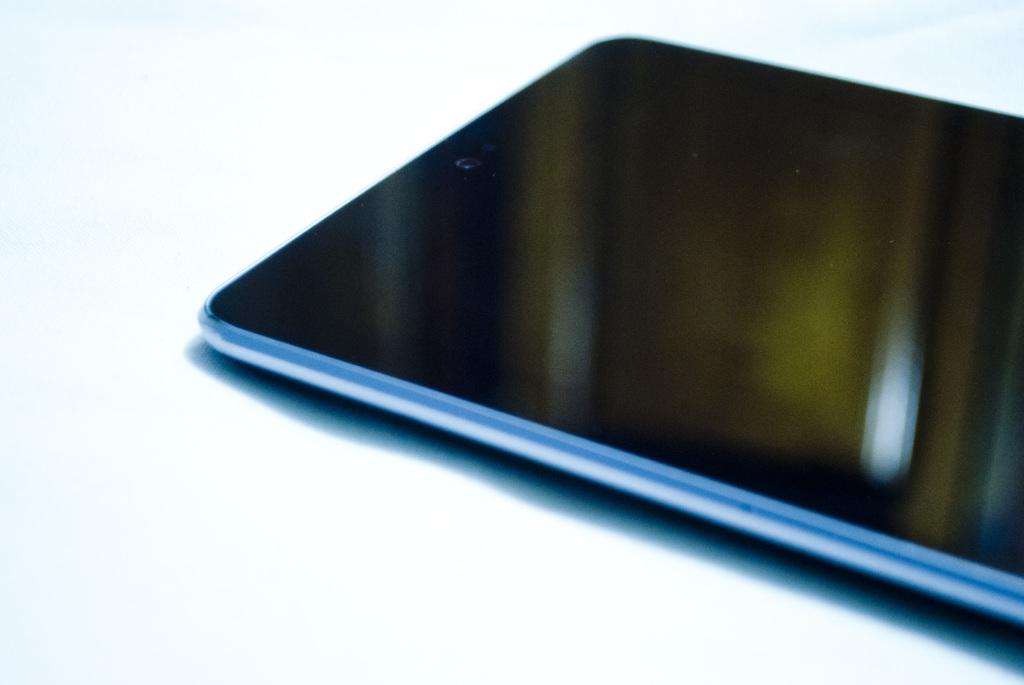What electronic device is in the center of the image? There is a mobile phone in the center of the image. Can you describe the position of the mobile phone in the image? The mobile phone is in the center of the image. What type of cast can be seen in the image? There is no cast present in the image. What scene is being depicted in the image? The image does not depict a scene; it only shows a mobile phone in the center. 